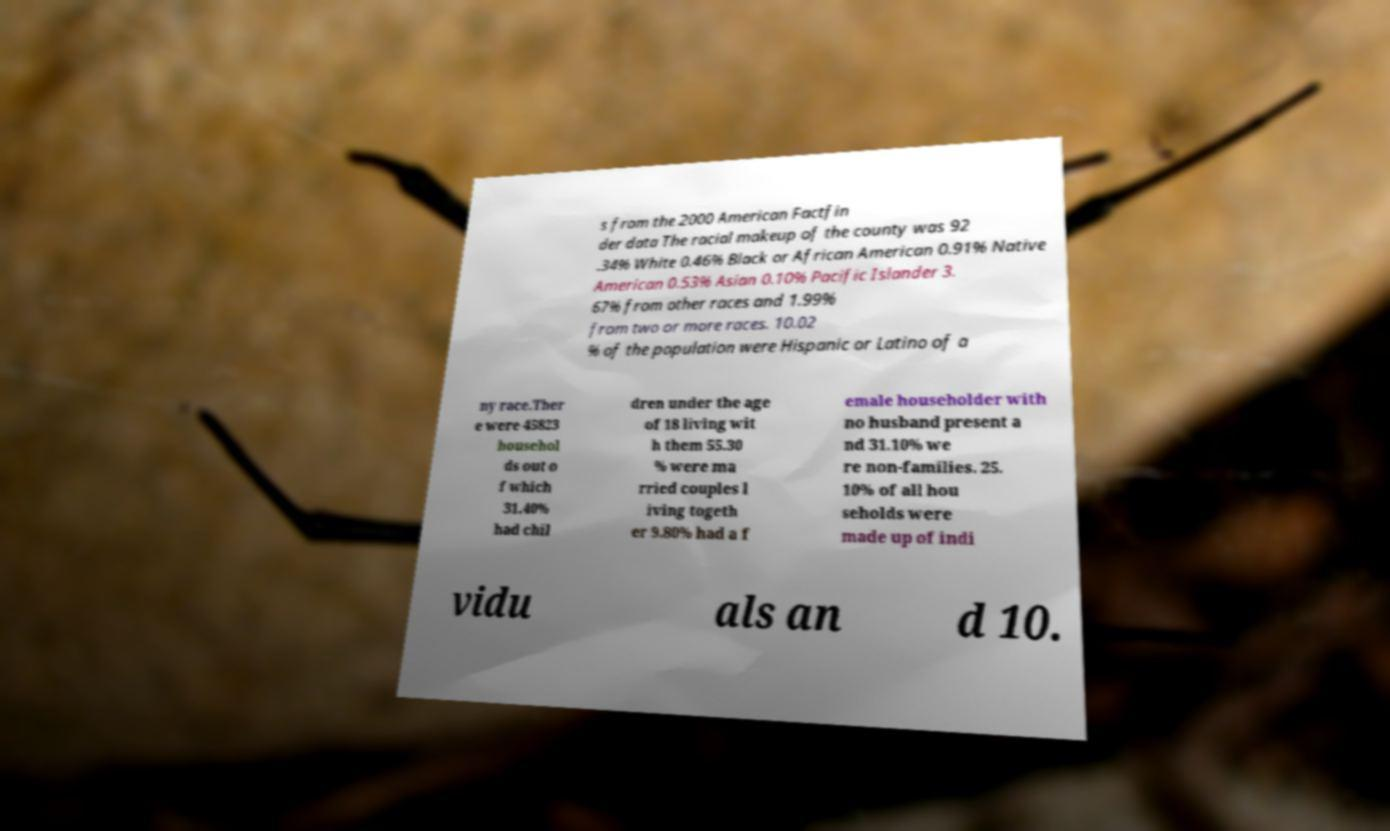Can you accurately transcribe the text from the provided image for me? s from the 2000 American Factfin der data The racial makeup of the county was 92 .34% White 0.46% Black or African American 0.91% Native American 0.53% Asian 0.10% Pacific Islander 3. 67% from other races and 1.99% from two or more races. 10.02 % of the population were Hispanic or Latino of a ny race.Ther e were 45823 househol ds out o f which 31.40% had chil dren under the age of 18 living wit h them 55.30 % were ma rried couples l iving togeth er 9.80% had a f emale householder with no husband present a nd 31.10% we re non-families. 25. 10% of all hou seholds were made up of indi vidu als an d 10. 